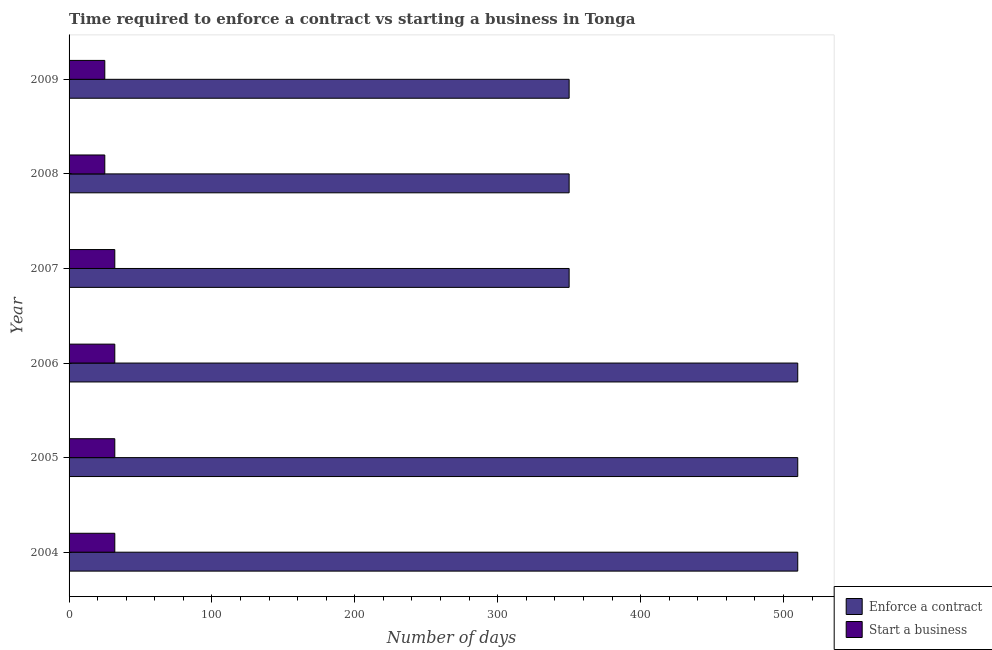How many groups of bars are there?
Provide a succinct answer. 6. Are the number of bars per tick equal to the number of legend labels?
Offer a very short reply. Yes. Are the number of bars on each tick of the Y-axis equal?
Provide a short and direct response. Yes. What is the number of days to start a business in 2004?
Provide a succinct answer. 32. Across all years, what is the maximum number of days to enforece a contract?
Your answer should be compact. 510. Across all years, what is the minimum number of days to enforece a contract?
Keep it short and to the point. 350. What is the total number of days to start a business in the graph?
Make the answer very short. 178. What is the difference between the number of days to enforece a contract in 2006 and that in 2007?
Give a very brief answer. 160. What is the difference between the number of days to enforece a contract in 2008 and the number of days to start a business in 2007?
Your answer should be compact. 318. What is the average number of days to start a business per year?
Your answer should be very brief. 29.67. In the year 2004, what is the difference between the number of days to enforece a contract and number of days to start a business?
Your response must be concise. 478. In how many years, is the number of days to start a business greater than 220 days?
Make the answer very short. 0. What is the ratio of the number of days to enforece a contract in 2005 to that in 2007?
Your response must be concise. 1.46. Is the number of days to enforece a contract in 2005 less than that in 2008?
Provide a succinct answer. No. Is the difference between the number of days to enforece a contract in 2004 and 2005 greater than the difference between the number of days to start a business in 2004 and 2005?
Provide a short and direct response. No. What is the difference between the highest and the second highest number of days to enforece a contract?
Ensure brevity in your answer.  0. What is the difference between the highest and the lowest number of days to enforece a contract?
Offer a very short reply. 160. In how many years, is the number of days to enforece a contract greater than the average number of days to enforece a contract taken over all years?
Provide a short and direct response. 3. Is the sum of the number of days to start a business in 2006 and 2009 greater than the maximum number of days to enforece a contract across all years?
Your response must be concise. No. What does the 2nd bar from the top in 2009 represents?
Ensure brevity in your answer.  Enforce a contract. What does the 1st bar from the bottom in 2004 represents?
Keep it short and to the point. Enforce a contract. How many bars are there?
Offer a very short reply. 12. Are all the bars in the graph horizontal?
Ensure brevity in your answer.  Yes. How many legend labels are there?
Offer a very short reply. 2. How are the legend labels stacked?
Your answer should be compact. Vertical. What is the title of the graph?
Make the answer very short. Time required to enforce a contract vs starting a business in Tonga. Does "Lowest 10% of population" appear as one of the legend labels in the graph?
Your response must be concise. No. What is the label or title of the X-axis?
Provide a succinct answer. Number of days. What is the Number of days of Enforce a contract in 2004?
Provide a short and direct response. 510. What is the Number of days in Start a business in 2004?
Make the answer very short. 32. What is the Number of days of Enforce a contract in 2005?
Your response must be concise. 510. What is the Number of days of Enforce a contract in 2006?
Provide a succinct answer. 510. What is the Number of days in Enforce a contract in 2007?
Your answer should be very brief. 350. What is the Number of days of Start a business in 2007?
Provide a succinct answer. 32. What is the Number of days of Enforce a contract in 2008?
Ensure brevity in your answer.  350. What is the Number of days of Enforce a contract in 2009?
Your answer should be compact. 350. What is the Number of days in Start a business in 2009?
Ensure brevity in your answer.  25. Across all years, what is the maximum Number of days of Enforce a contract?
Provide a short and direct response. 510. Across all years, what is the minimum Number of days in Enforce a contract?
Make the answer very short. 350. Across all years, what is the minimum Number of days in Start a business?
Offer a very short reply. 25. What is the total Number of days of Enforce a contract in the graph?
Provide a short and direct response. 2580. What is the total Number of days in Start a business in the graph?
Keep it short and to the point. 178. What is the difference between the Number of days of Start a business in 2004 and that in 2006?
Make the answer very short. 0. What is the difference between the Number of days of Enforce a contract in 2004 and that in 2007?
Your answer should be compact. 160. What is the difference between the Number of days in Start a business in 2004 and that in 2007?
Offer a terse response. 0. What is the difference between the Number of days in Enforce a contract in 2004 and that in 2008?
Ensure brevity in your answer.  160. What is the difference between the Number of days in Enforce a contract in 2004 and that in 2009?
Offer a very short reply. 160. What is the difference between the Number of days in Enforce a contract in 2005 and that in 2006?
Make the answer very short. 0. What is the difference between the Number of days of Start a business in 2005 and that in 2006?
Ensure brevity in your answer.  0. What is the difference between the Number of days of Enforce a contract in 2005 and that in 2007?
Your answer should be very brief. 160. What is the difference between the Number of days of Enforce a contract in 2005 and that in 2008?
Offer a very short reply. 160. What is the difference between the Number of days of Start a business in 2005 and that in 2008?
Provide a succinct answer. 7. What is the difference between the Number of days in Enforce a contract in 2005 and that in 2009?
Your answer should be compact. 160. What is the difference between the Number of days of Start a business in 2005 and that in 2009?
Provide a short and direct response. 7. What is the difference between the Number of days of Enforce a contract in 2006 and that in 2007?
Make the answer very short. 160. What is the difference between the Number of days of Enforce a contract in 2006 and that in 2008?
Offer a very short reply. 160. What is the difference between the Number of days in Start a business in 2006 and that in 2008?
Make the answer very short. 7. What is the difference between the Number of days in Enforce a contract in 2006 and that in 2009?
Offer a terse response. 160. What is the difference between the Number of days of Start a business in 2006 and that in 2009?
Your answer should be compact. 7. What is the difference between the Number of days of Enforce a contract in 2007 and that in 2008?
Provide a short and direct response. 0. What is the difference between the Number of days of Start a business in 2007 and that in 2008?
Your answer should be very brief. 7. What is the difference between the Number of days in Enforce a contract in 2007 and that in 2009?
Offer a terse response. 0. What is the difference between the Number of days in Start a business in 2007 and that in 2009?
Ensure brevity in your answer.  7. What is the difference between the Number of days of Enforce a contract in 2004 and the Number of days of Start a business in 2005?
Your response must be concise. 478. What is the difference between the Number of days of Enforce a contract in 2004 and the Number of days of Start a business in 2006?
Keep it short and to the point. 478. What is the difference between the Number of days of Enforce a contract in 2004 and the Number of days of Start a business in 2007?
Your response must be concise. 478. What is the difference between the Number of days of Enforce a contract in 2004 and the Number of days of Start a business in 2008?
Offer a terse response. 485. What is the difference between the Number of days of Enforce a contract in 2004 and the Number of days of Start a business in 2009?
Keep it short and to the point. 485. What is the difference between the Number of days of Enforce a contract in 2005 and the Number of days of Start a business in 2006?
Your response must be concise. 478. What is the difference between the Number of days of Enforce a contract in 2005 and the Number of days of Start a business in 2007?
Provide a short and direct response. 478. What is the difference between the Number of days in Enforce a contract in 2005 and the Number of days in Start a business in 2008?
Ensure brevity in your answer.  485. What is the difference between the Number of days in Enforce a contract in 2005 and the Number of days in Start a business in 2009?
Provide a succinct answer. 485. What is the difference between the Number of days of Enforce a contract in 2006 and the Number of days of Start a business in 2007?
Provide a succinct answer. 478. What is the difference between the Number of days in Enforce a contract in 2006 and the Number of days in Start a business in 2008?
Ensure brevity in your answer.  485. What is the difference between the Number of days in Enforce a contract in 2006 and the Number of days in Start a business in 2009?
Your response must be concise. 485. What is the difference between the Number of days in Enforce a contract in 2007 and the Number of days in Start a business in 2008?
Your answer should be very brief. 325. What is the difference between the Number of days of Enforce a contract in 2007 and the Number of days of Start a business in 2009?
Offer a very short reply. 325. What is the difference between the Number of days of Enforce a contract in 2008 and the Number of days of Start a business in 2009?
Offer a very short reply. 325. What is the average Number of days in Enforce a contract per year?
Keep it short and to the point. 430. What is the average Number of days of Start a business per year?
Keep it short and to the point. 29.67. In the year 2004, what is the difference between the Number of days of Enforce a contract and Number of days of Start a business?
Offer a terse response. 478. In the year 2005, what is the difference between the Number of days of Enforce a contract and Number of days of Start a business?
Ensure brevity in your answer.  478. In the year 2006, what is the difference between the Number of days of Enforce a contract and Number of days of Start a business?
Offer a very short reply. 478. In the year 2007, what is the difference between the Number of days of Enforce a contract and Number of days of Start a business?
Ensure brevity in your answer.  318. In the year 2008, what is the difference between the Number of days of Enforce a contract and Number of days of Start a business?
Your answer should be compact. 325. In the year 2009, what is the difference between the Number of days in Enforce a contract and Number of days in Start a business?
Keep it short and to the point. 325. What is the ratio of the Number of days in Start a business in 2004 to that in 2005?
Offer a very short reply. 1. What is the ratio of the Number of days in Start a business in 2004 to that in 2006?
Offer a terse response. 1. What is the ratio of the Number of days of Enforce a contract in 2004 to that in 2007?
Your answer should be compact. 1.46. What is the ratio of the Number of days in Start a business in 2004 to that in 2007?
Provide a short and direct response. 1. What is the ratio of the Number of days in Enforce a contract in 2004 to that in 2008?
Give a very brief answer. 1.46. What is the ratio of the Number of days of Start a business in 2004 to that in 2008?
Offer a very short reply. 1.28. What is the ratio of the Number of days in Enforce a contract in 2004 to that in 2009?
Offer a very short reply. 1.46. What is the ratio of the Number of days in Start a business in 2004 to that in 2009?
Provide a succinct answer. 1.28. What is the ratio of the Number of days of Enforce a contract in 2005 to that in 2006?
Ensure brevity in your answer.  1. What is the ratio of the Number of days in Start a business in 2005 to that in 2006?
Offer a very short reply. 1. What is the ratio of the Number of days of Enforce a contract in 2005 to that in 2007?
Give a very brief answer. 1.46. What is the ratio of the Number of days of Start a business in 2005 to that in 2007?
Give a very brief answer. 1. What is the ratio of the Number of days of Enforce a contract in 2005 to that in 2008?
Your response must be concise. 1.46. What is the ratio of the Number of days of Start a business in 2005 to that in 2008?
Keep it short and to the point. 1.28. What is the ratio of the Number of days of Enforce a contract in 2005 to that in 2009?
Your answer should be very brief. 1.46. What is the ratio of the Number of days in Start a business in 2005 to that in 2009?
Offer a very short reply. 1.28. What is the ratio of the Number of days in Enforce a contract in 2006 to that in 2007?
Provide a succinct answer. 1.46. What is the ratio of the Number of days of Enforce a contract in 2006 to that in 2008?
Provide a succinct answer. 1.46. What is the ratio of the Number of days of Start a business in 2006 to that in 2008?
Your answer should be compact. 1.28. What is the ratio of the Number of days of Enforce a contract in 2006 to that in 2009?
Your answer should be very brief. 1.46. What is the ratio of the Number of days of Start a business in 2006 to that in 2009?
Provide a succinct answer. 1.28. What is the ratio of the Number of days of Start a business in 2007 to that in 2008?
Offer a very short reply. 1.28. What is the ratio of the Number of days of Start a business in 2007 to that in 2009?
Provide a short and direct response. 1.28. What is the ratio of the Number of days in Start a business in 2008 to that in 2009?
Your answer should be very brief. 1. What is the difference between the highest and the second highest Number of days of Enforce a contract?
Ensure brevity in your answer.  0. What is the difference between the highest and the lowest Number of days in Enforce a contract?
Offer a terse response. 160. 